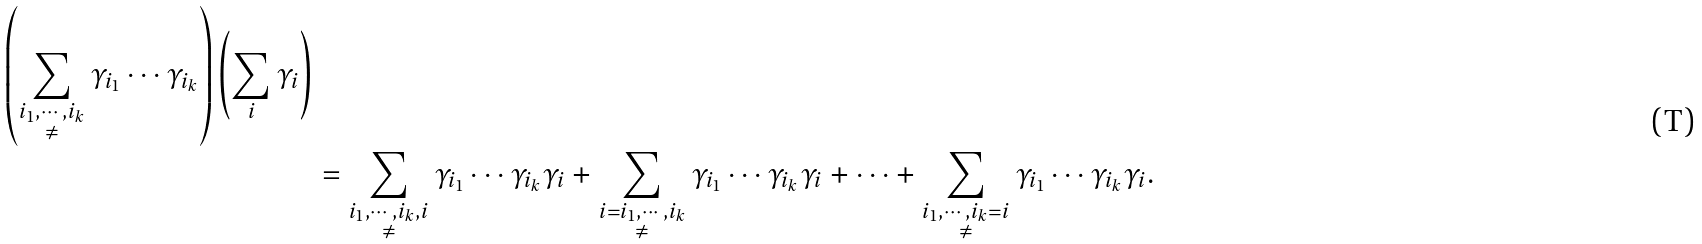Convert formula to latex. <formula><loc_0><loc_0><loc_500><loc_500>{ \left ( \sum _ { \substack { i _ { 1 } , \cdots , i _ { k } \\ \ne } } \gamma _ { i _ { 1 } } \cdots \gamma _ { i _ { k } } \right ) \left ( \sum _ { i } \gamma _ { i } \right ) } \\ & = \sum _ { \substack { i _ { 1 } , \cdots , i _ { k } , i \\ \ne } } \gamma _ { i _ { 1 } } \cdots \gamma _ { i _ { k } } \gamma _ { i } + \sum _ { \substack { i = i _ { 1 } , \cdots , i _ { k } \\ \ne } } \gamma _ { i _ { 1 } } \cdots \gamma _ { i _ { k } } \gamma _ { i } + \cdots + \sum _ { \substack { i _ { 1 } , \cdots , i _ { k } = i \\ \ne } } \gamma _ { i _ { 1 } } \cdots \gamma _ { i _ { k } } \gamma _ { i } .</formula> 